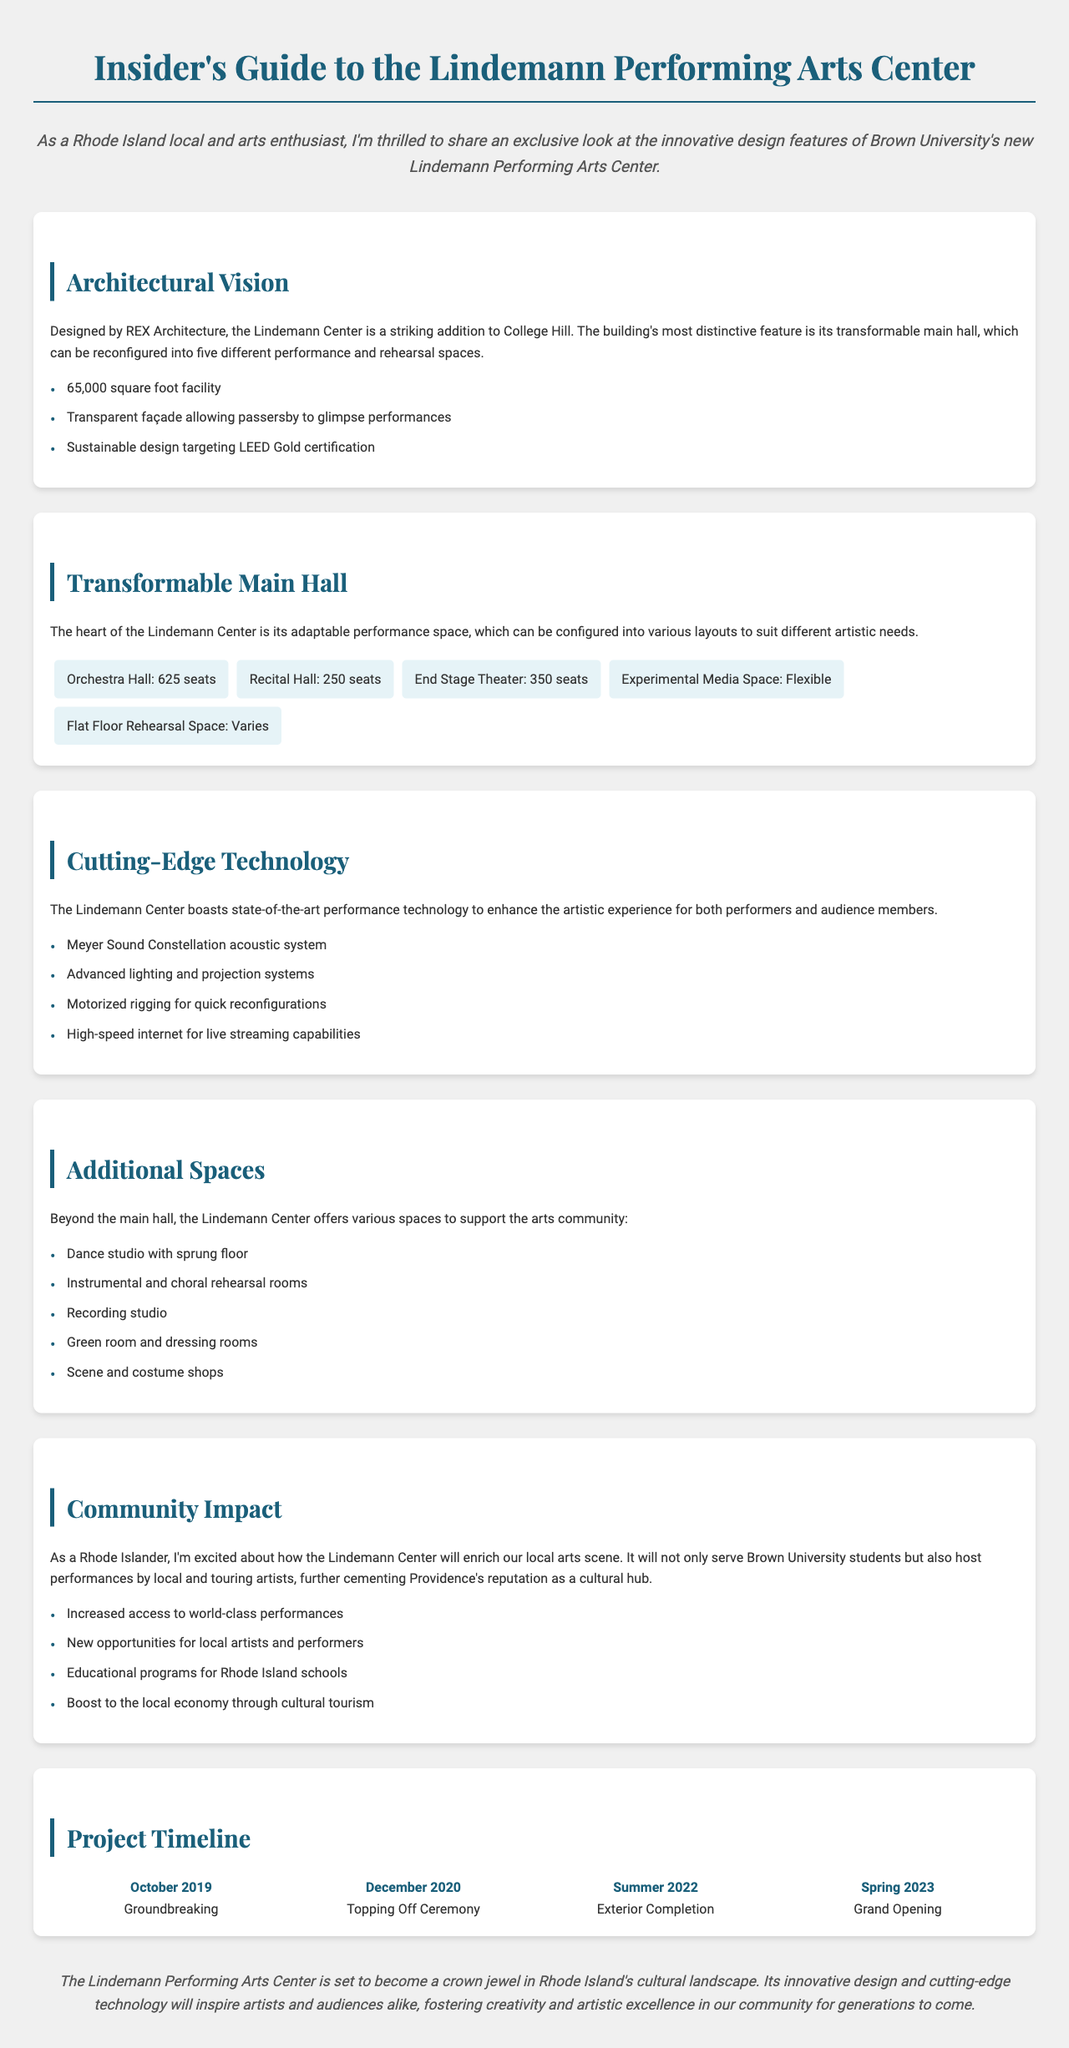What is the total square footage of the Lindemann Performing Arts Center? The total square footage is mentioned in the document as a key point under the "Architectural Vision" section.
Answer: 65,000 square foot facility Who designed the Lindemann Performing Arts Center? The designer of the center is stated in the "Architectural Vision" section.
Answer: REX Architecture How many configurations can the main hall be reconfigured into? The document specifies this in the "Transformable Main Hall" section.
Answer: Five different performance and rehearsal spaces What is the purpose of the Meyer Sound Constellation system? The purpose is described under the "Cutting-Edge Technology" section as enhancing the artistic experience.
Answer: Acoustic system When was the Grand Opening of the Lindemann Performing Arts Center? The date is outlined in the "Project Timeline" section of the document.
Answer: Spring 2023 What type of floor does the dance studio have? This information is found under the "Additional Spaces" section of the document.
Answer: Sprung floor What certification is the Lindemann Center targeting for sustainability? This is a key point in the "Architectural Vision" section concerning sustainable design.
Answer: LEED Gold certification What will the center provide to Rhode Island schools? This benefit is highlighted in the "Community Impact" section of the document.
Answer: Educational programs for Rhode Island schools 